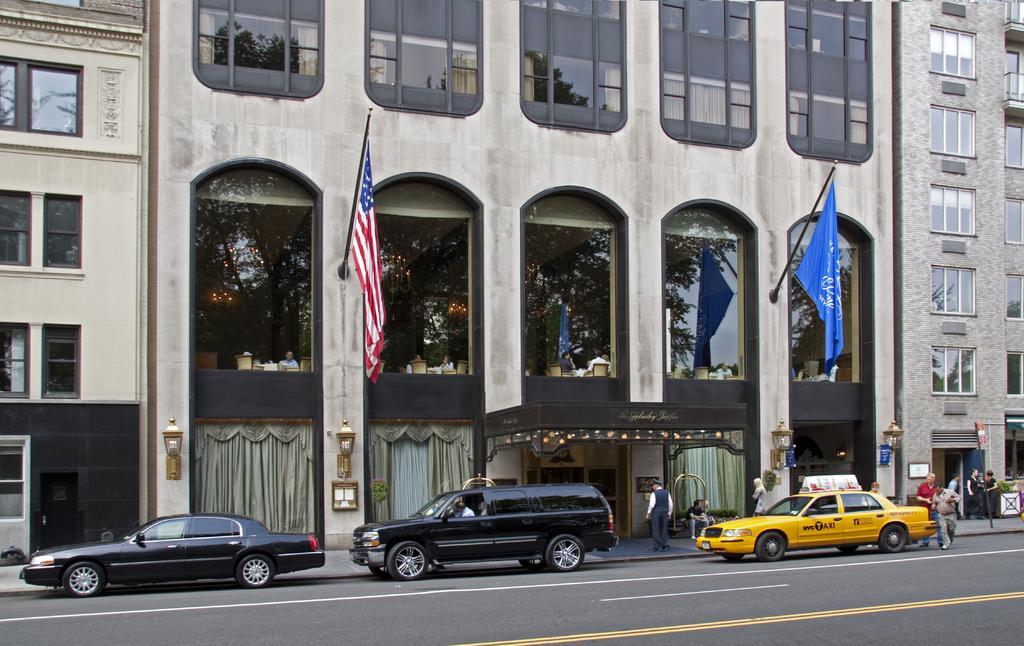Can you describe this image briefly? In this image, at the bottom there are cars, people, windows, curtains, road, objects. At the top there are buildings, flags, poles, windows, glasses, people, chairs, curtains, lamps, text and a wall. 